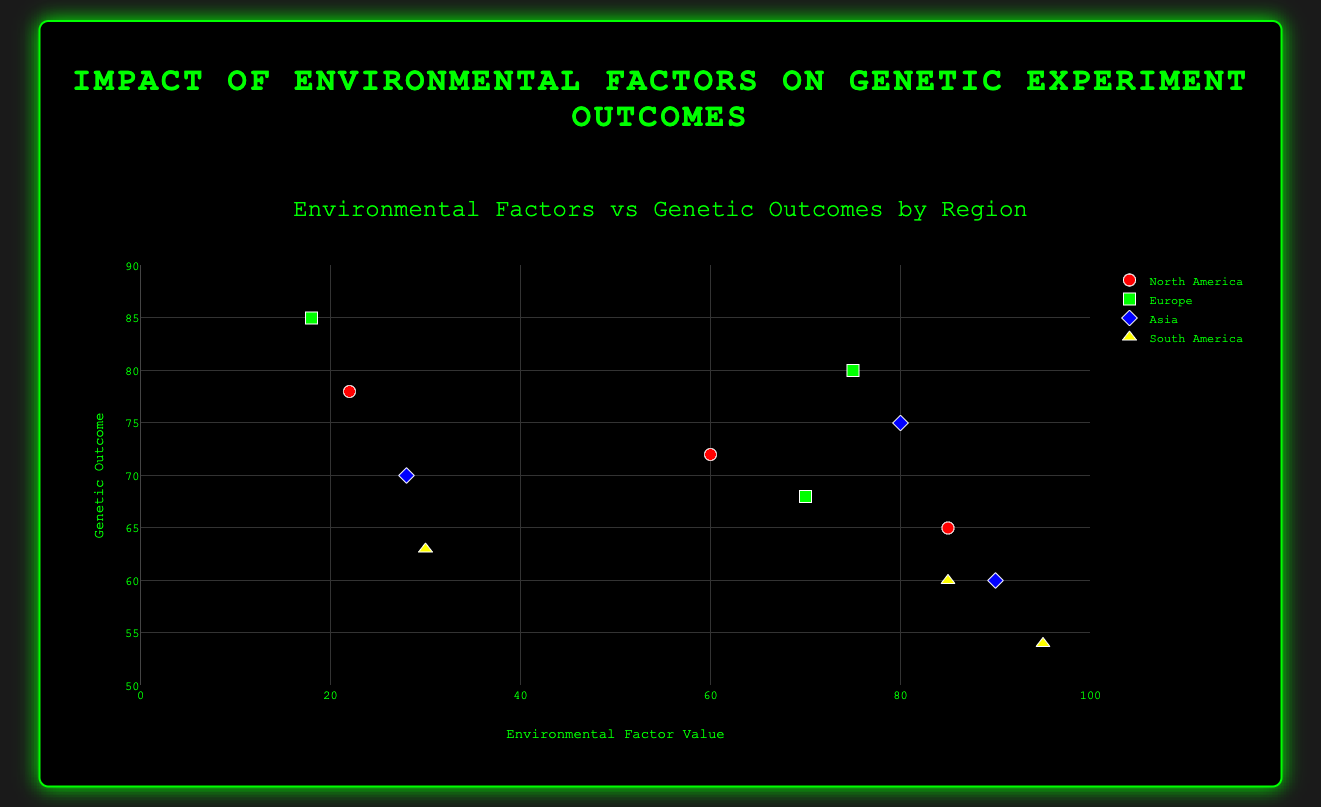What is the title of the figure? The title is shown at the top of the figure. It is in a larger font size and describes the overall content of the plot.
Answer: Environmental Factors vs Genetic Outcomes by Region Which region shows the highest genetic outcome for temperature? By observing the plot, we see that the data point with the highest genetic outcome for temperature is in the region labeled "Europe."
Answer: Europe How many regions are represented in the figure? The figure shows data points grouped by regions, with colors and legends indicating different regions. There are four distinct regions displayed.
Answer: Four What is the rank order of genetic outcomes for North America's environmental factors from highest to lowest? For North America, look at the genetic outcomes for temperature, precipitation, and humidity. We rank them as follows: Temperature (78), Humidity (72), and Precipitation (65).
Answer: 78, 72, 65 Which environmental factor has the lowest genetic outcome in South America? Examine the genetic outcomes for temperature, precipitation, and humidity in South America. The lowest outcome observed is for precipitation with a value of 54.
Answer: Precipitation Compare the genetic outcomes for humidity in all regions. Which region has the highest value? Look at the genetic outcomes for humidity across regions. The maximum value is seen in Europe with an outcome of 80.
Answer: Europe What is the average genetic outcome for precipitation in all the regions? Calculate the average by summing up the genetic outcomes for precipitation across North America, Europe, Asia, and South America (65 + 68 + 60 + 54) and then divide by 4. The average is (65 + 68 + 60 + 54)/4 = 61.75
Answer: 61.75 Is there a consistent trend between temperature values and genetic outcomes across the regions? Observe the scatter plot to examine if higher or lower temperature values consistently correspond to higher or lower genetic outcomes across the different regions. No consistent trend is noticeable as the relationships vary.
Answer: No Which region's genetic outcome is most affected by humidity? Compare the difference in genetic outcomes between the highest and lowest values for each region for the environmental factor humidity. Europe's genetic outcome for humidity shows a significant value of 80, which is distinctly high compared to other regions.
Answer: Europe Does any region have the same genetic outcome for two different environmental factors? Examine genetic outcomes across different environmental factors in each region. Asia has identical genetic outcomes for humidity (75) and temperature (75).
Answer: No How does the genetic outcome for precipitation in North America compare to that in Europe? Compare the genetic outcome data points for precipitation in North America and Europe. North America's genetic outcome is 65, whereas Europe's is 68.
Answer: Europe's is higher 